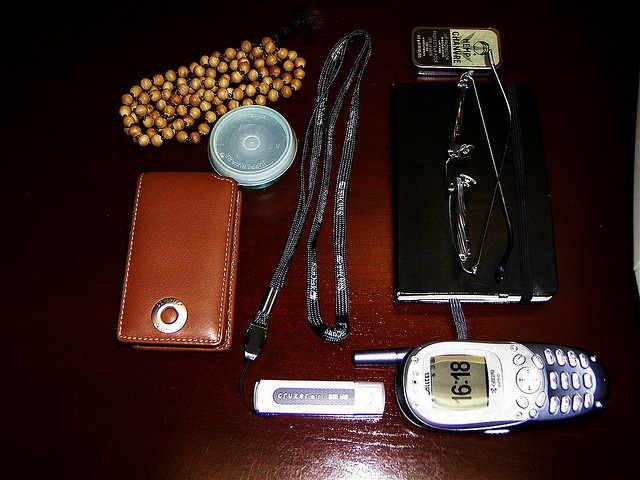Describe the objects in this image and their specific colors. I can see a cell phone in black, white, and gray tones in this image. 